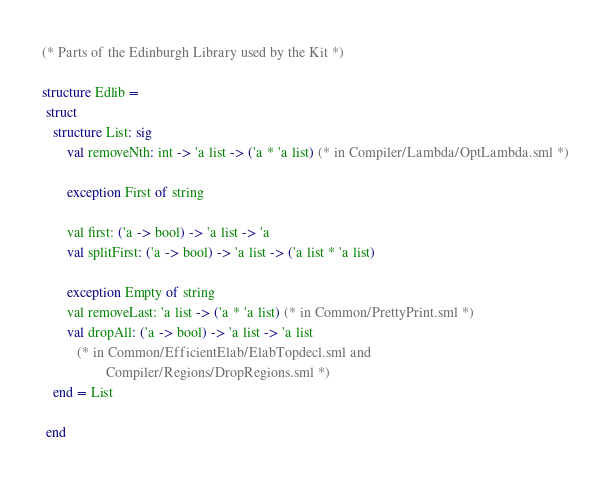<code> <loc_0><loc_0><loc_500><loc_500><_SML_>(* Parts of the Edinburgh Library used by the Kit *)

structure Edlib =
 struct
   structure List: sig
       val removeNth: int -> 'a list -> ('a * 'a list) (* in Compiler/Lambda/OptLambda.sml *)

       exception First of string

       val first: ('a -> bool) -> 'a list -> 'a
       val splitFirst: ('a -> bool) -> 'a list -> ('a list * 'a list)

       exception Empty of string
       val removeLast: 'a list -> ('a * 'a list) (* in Common/PrettyPrint.sml *)
       val dropAll: ('a -> bool) -> 'a list -> 'a list 
          (* in Common/EfficientElab/ElabTopdecl.sml and
                Compiler/Regions/DropRegions.sml *)
   end = List

 end
</code> 